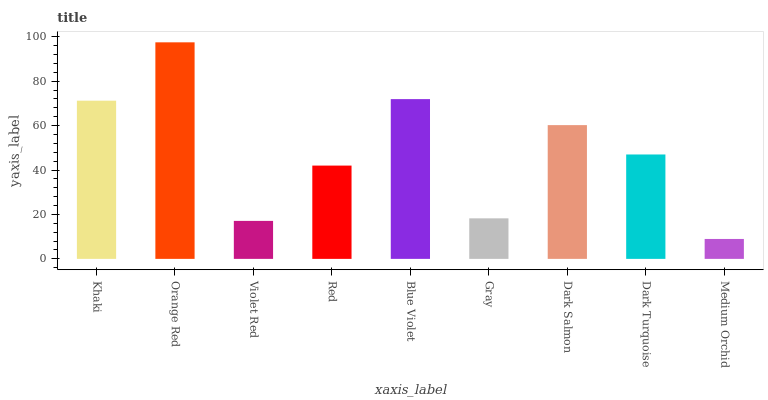Is Medium Orchid the minimum?
Answer yes or no. Yes. Is Orange Red the maximum?
Answer yes or no. Yes. Is Violet Red the minimum?
Answer yes or no. No. Is Violet Red the maximum?
Answer yes or no. No. Is Orange Red greater than Violet Red?
Answer yes or no. Yes. Is Violet Red less than Orange Red?
Answer yes or no. Yes. Is Violet Red greater than Orange Red?
Answer yes or no. No. Is Orange Red less than Violet Red?
Answer yes or no. No. Is Dark Turquoise the high median?
Answer yes or no. Yes. Is Dark Turquoise the low median?
Answer yes or no. Yes. Is Blue Violet the high median?
Answer yes or no. No. Is Orange Red the low median?
Answer yes or no. No. 